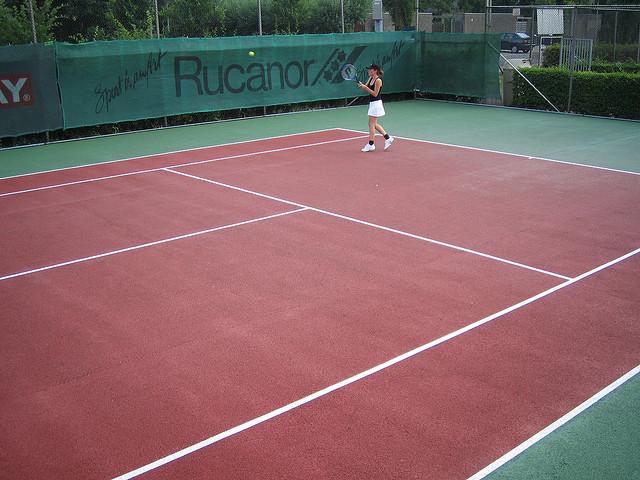Are there spectators visible?
Concise answer only. No. What color is the court?
Be succinct. Red. Are the hedges trimmed up nicely?
Be succinct. Yes. 